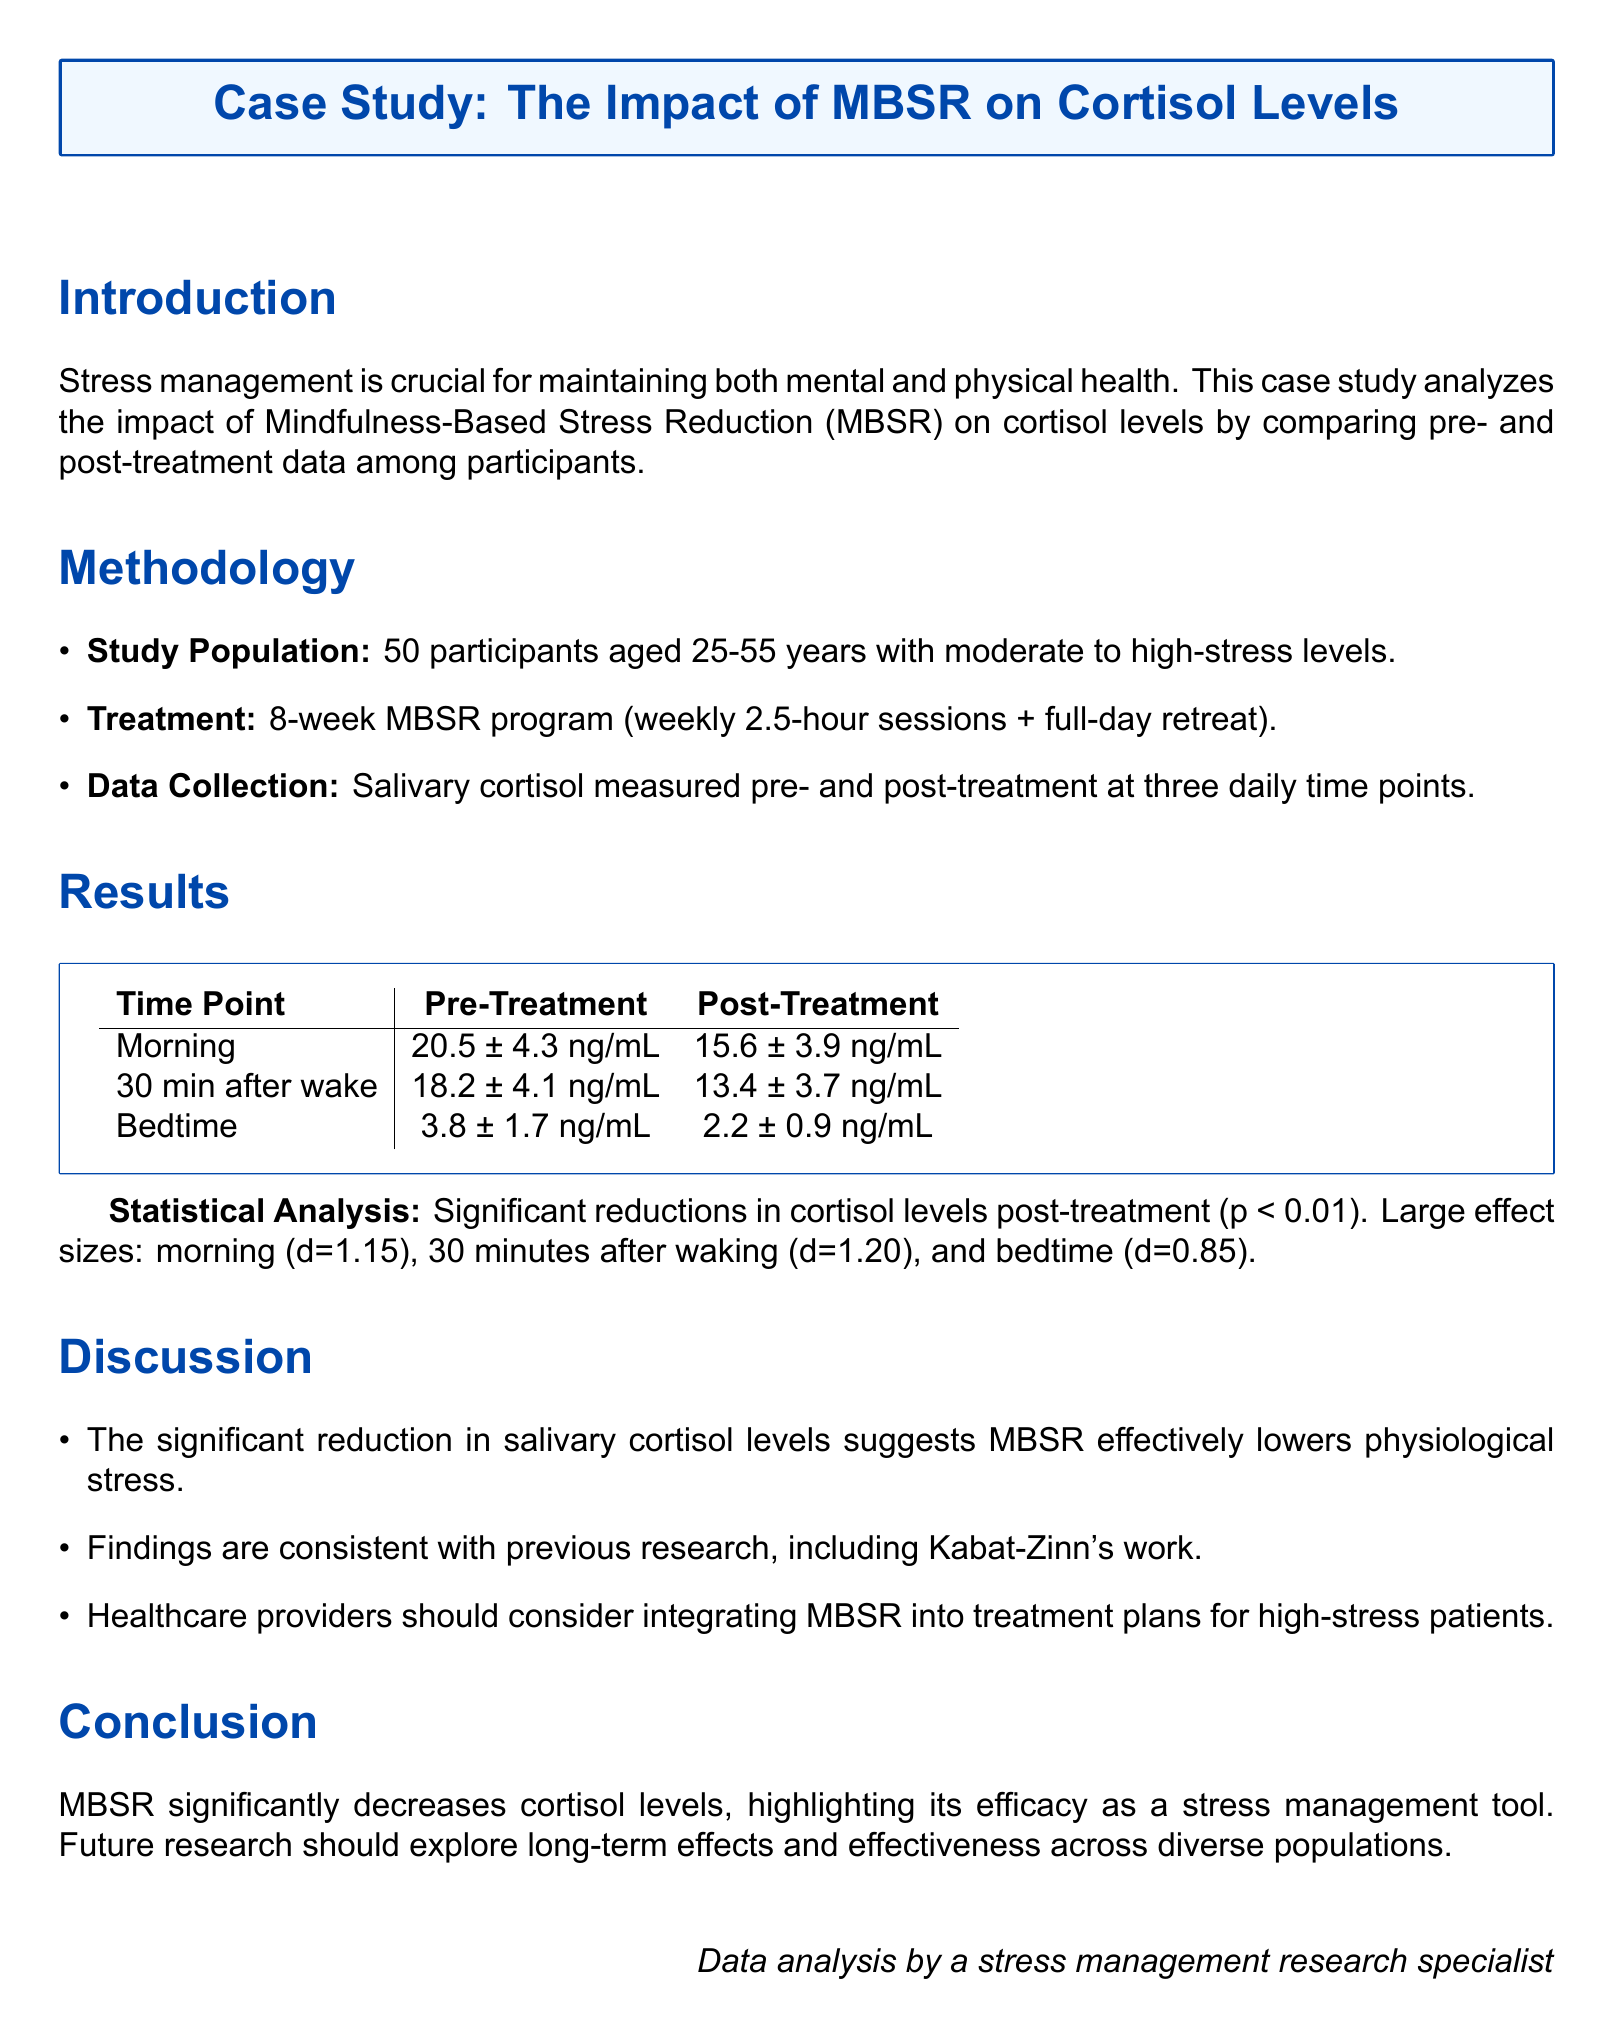What is the age range of participants? The study population includes participants aged 25-55 years.
Answer: 25-55 years How long is the MBSR program? The MBSR program lasts for 8 weeks.
Answer: 8 weeks What was the morning cortisol level pre-treatment? The pre-treatment cortisol level in the morning was measured at 20.5 ng/mL.
Answer: 20.5 ng/mL What was the p-value indicating the significance of the treatment effect? The treatment effect was significant with a p-value of less than 0.01.
Answer: p < 0.01 What was the effect size for cortisol level 30 minutes after waking? The effect size for cortisol level 30 minutes after waking was d=1.20.
Answer: d=1.20 What type of stress management technique is this study focusing on? The study focuses on Mindfulness-Based Stress Reduction (MBSR).
Answer: Mindfulness-Based Stress Reduction (MBSR) What is the main conclusion of the study? The main conclusion is that MBSR significantly decreases cortisol levels.
Answer: Significantly decreases cortisol levels What is the cortisol level at bedtime post-treatment? The post-treatment cortisol level at bedtime was found to be 2.2 ng/mL.
Answer: 2.2 ng/mL 